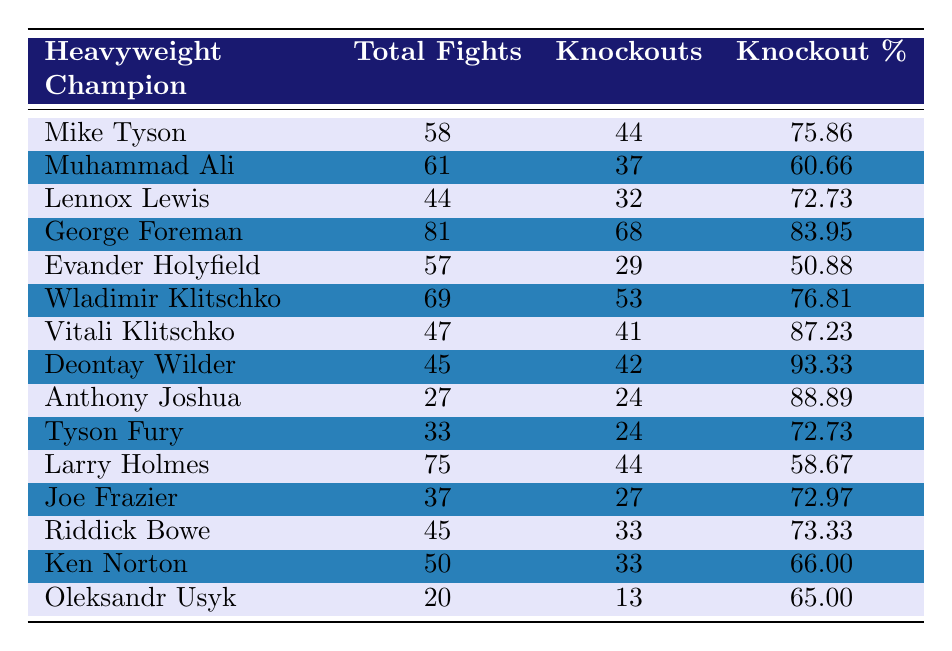What is the knockout percentage of Deontay Wilder? The table directly lists Deontay Wilder's knockout percentage as 93.33.
Answer: 93.33 Which heavyweight champion has the highest knockout percentage? By comparing the knockout percentages in the table, Deontay Wilder has the highest percentage at 93.33.
Answer: Deontay Wilder How many total fights did Muhammad Ali have? The table shows that Muhammad Ali had a total of 61 fights.
Answer: 61 Who is the heavyweight champion with the lowest knockout percentage? By checking the knockout percentages, Evander Holyfield has the lowest at 50.88.
Answer: Evander Holyfield What is the average knockout percentage of the Klitschko brothers? The knockout percentages for Wladimir Klitschko and Vitali Klitschko are 76.81 and 87.23, respectively. The average is (76.81 + 87.23) / 2 = 82.02.
Answer: 82.02 How many champions had more than 40 knockouts in their career? By examining the knockouts column, Mike Tyson, George Foreman, Wladimir Klitschko, Vitali Klitschko, Deontay Wilder, and Riddick Bowe all had more than 40 knockouts, totaling 6 champions.
Answer: 6 Is it true that Larry Holmes had more fights than George Foreman? Larry Holmes had 75 fights, while George Foreman had 81 fights, so the statement is false.
Answer: No What is the total number of knockouts by all champions listed? Adding all the knockouts from the table: 44 + 37 + 32 + 68 + 29 + 53 + 41 + 42 + 24 + 24 + 44 + 27 + 33 + 33 + 13 =  507.
Answer: 507 Which heavyweight champion had a higher knockout percentage, Lennox Lewis or Joe Frazier? Lennox Lewis has a knockout percentage of 72.73 while Joe Frazier has 72.97. Therefore, Joe Frazier has a slightly higher percentage.
Answer: Joe Frazier What is the percentage difference in knockouts between Tyson Fury and Evander Holyfield? Tyson Fury has 72.73% and Evander Holyfield has 50.88%. The difference is 72.73 - 50.88 = 21.85.
Answer: 21.85 